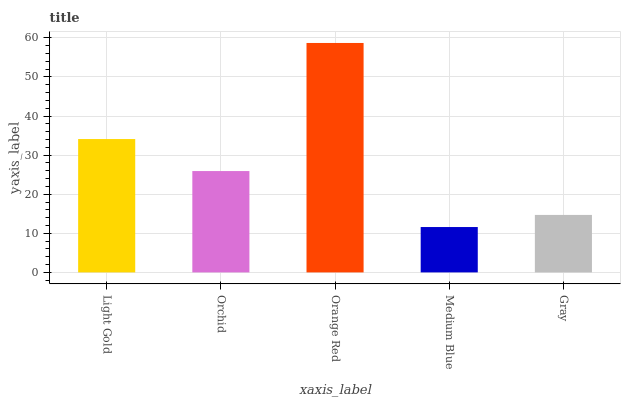Is Medium Blue the minimum?
Answer yes or no. Yes. Is Orange Red the maximum?
Answer yes or no. Yes. Is Orchid the minimum?
Answer yes or no. No. Is Orchid the maximum?
Answer yes or no. No. Is Light Gold greater than Orchid?
Answer yes or no. Yes. Is Orchid less than Light Gold?
Answer yes or no. Yes. Is Orchid greater than Light Gold?
Answer yes or no. No. Is Light Gold less than Orchid?
Answer yes or no. No. Is Orchid the high median?
Answer yes or no. Yes. Is Orchid the low median?
Answer yes or no. Yes. Is Orange Red the high median?
Answer yes or no. No. Is Gray the low median?
Answer yes or no. No. 